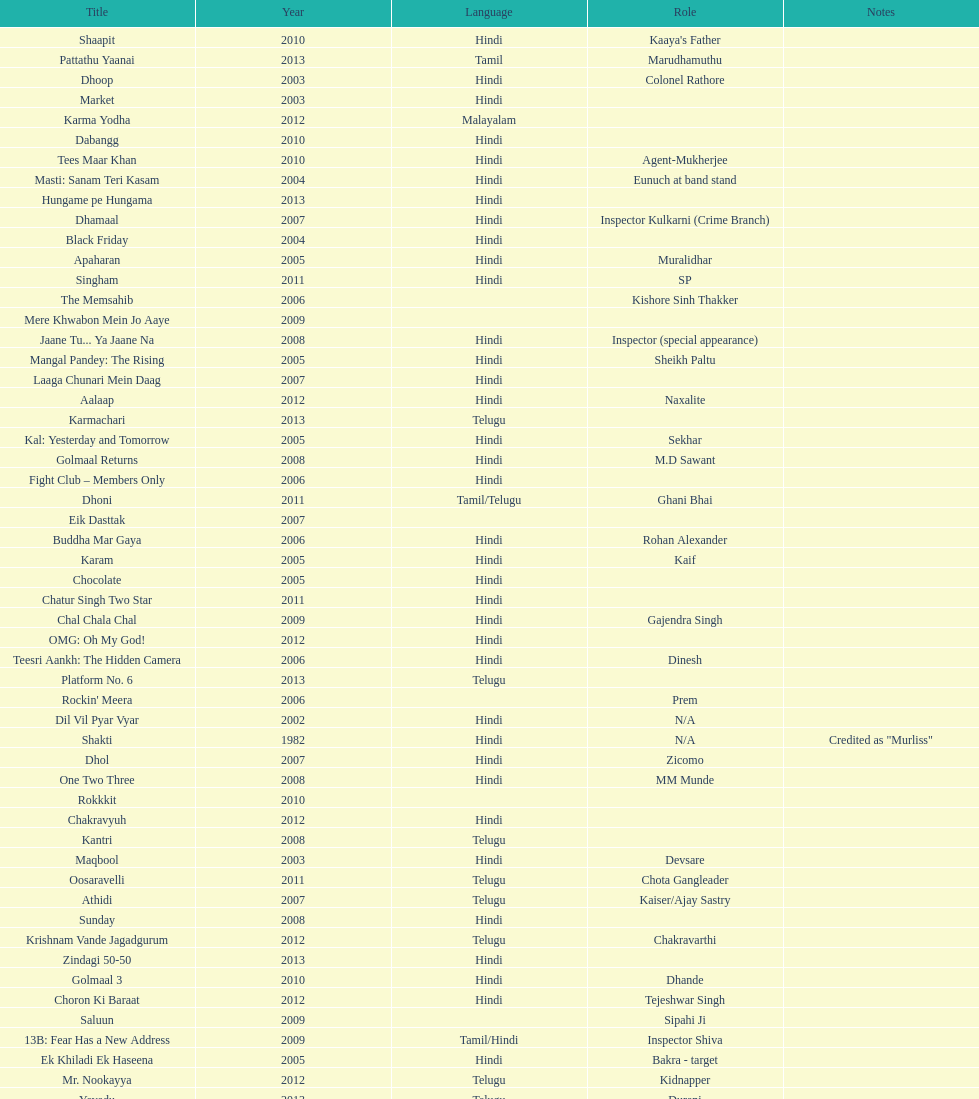What movie did this actor star in after they starred in dil vil pyar vyar in 2002? Maqbool. 